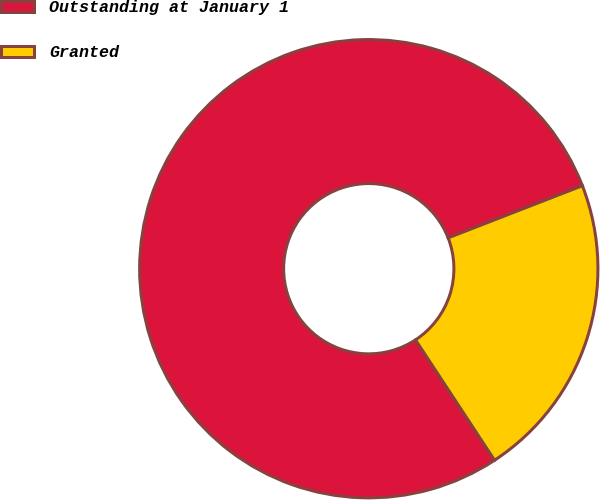<chart> <loc_0><loc_0><loc_500><loc_500><pie_chart><fcel>Outstanding at January 1<fcel>Granted<nl><fcel>78.35%<fcel>21.65%<nl></chart> 